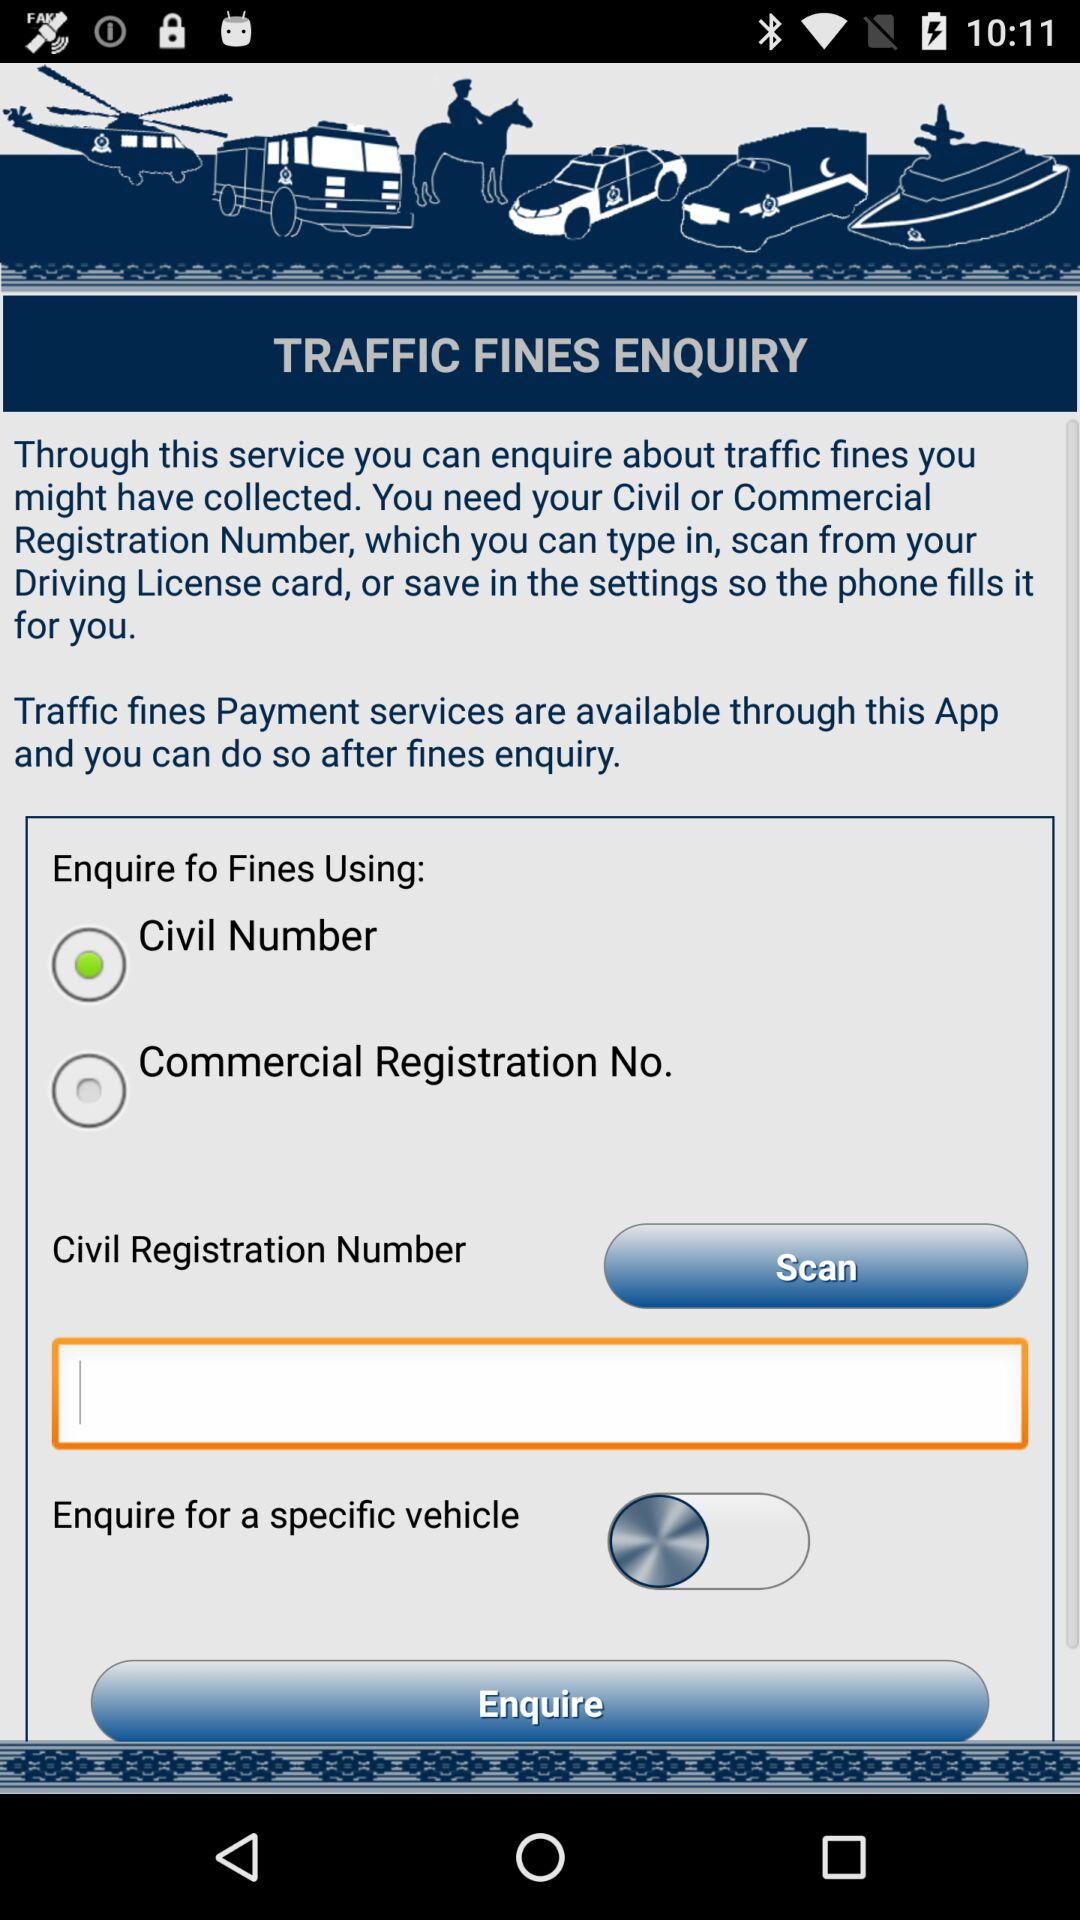Which type of registration number do we need to inquire about traffic fines? To inquire about traffic fines, you need a Civil or Commercial registration number. 